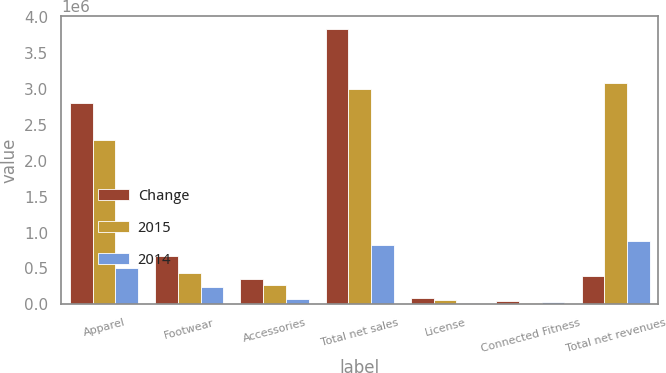Convert chart. <chart><loc_0><loc_0><loc_500><loc_500><stacked_bar_chart><ecel><fcel>Apparel<fcel>Footwear<fcel>Accessories<fcel>Total net sales<fcel>License<fcel>Connected Fitness<fcel>Total net revenues<nl><fcel>Change<fcel>2.80106e+06<fcel>677744<fcel>346885<fcel>3.82569e+06<fcel>84207<fcel>53415<fcel>388936<nl><fcel>2015<fcel>2.29152e+06<fcel>430987<fcel>275409<fcel>2.99792e+06<fcel>67229<fcel>19225<fcel>3.08437e+06<nl><fcel>2014<fcel>509542<fcel>246757<fcel>71476<fcel>827775<fcel>16978<fcel>34190<fcel>878943<nl></chart> 